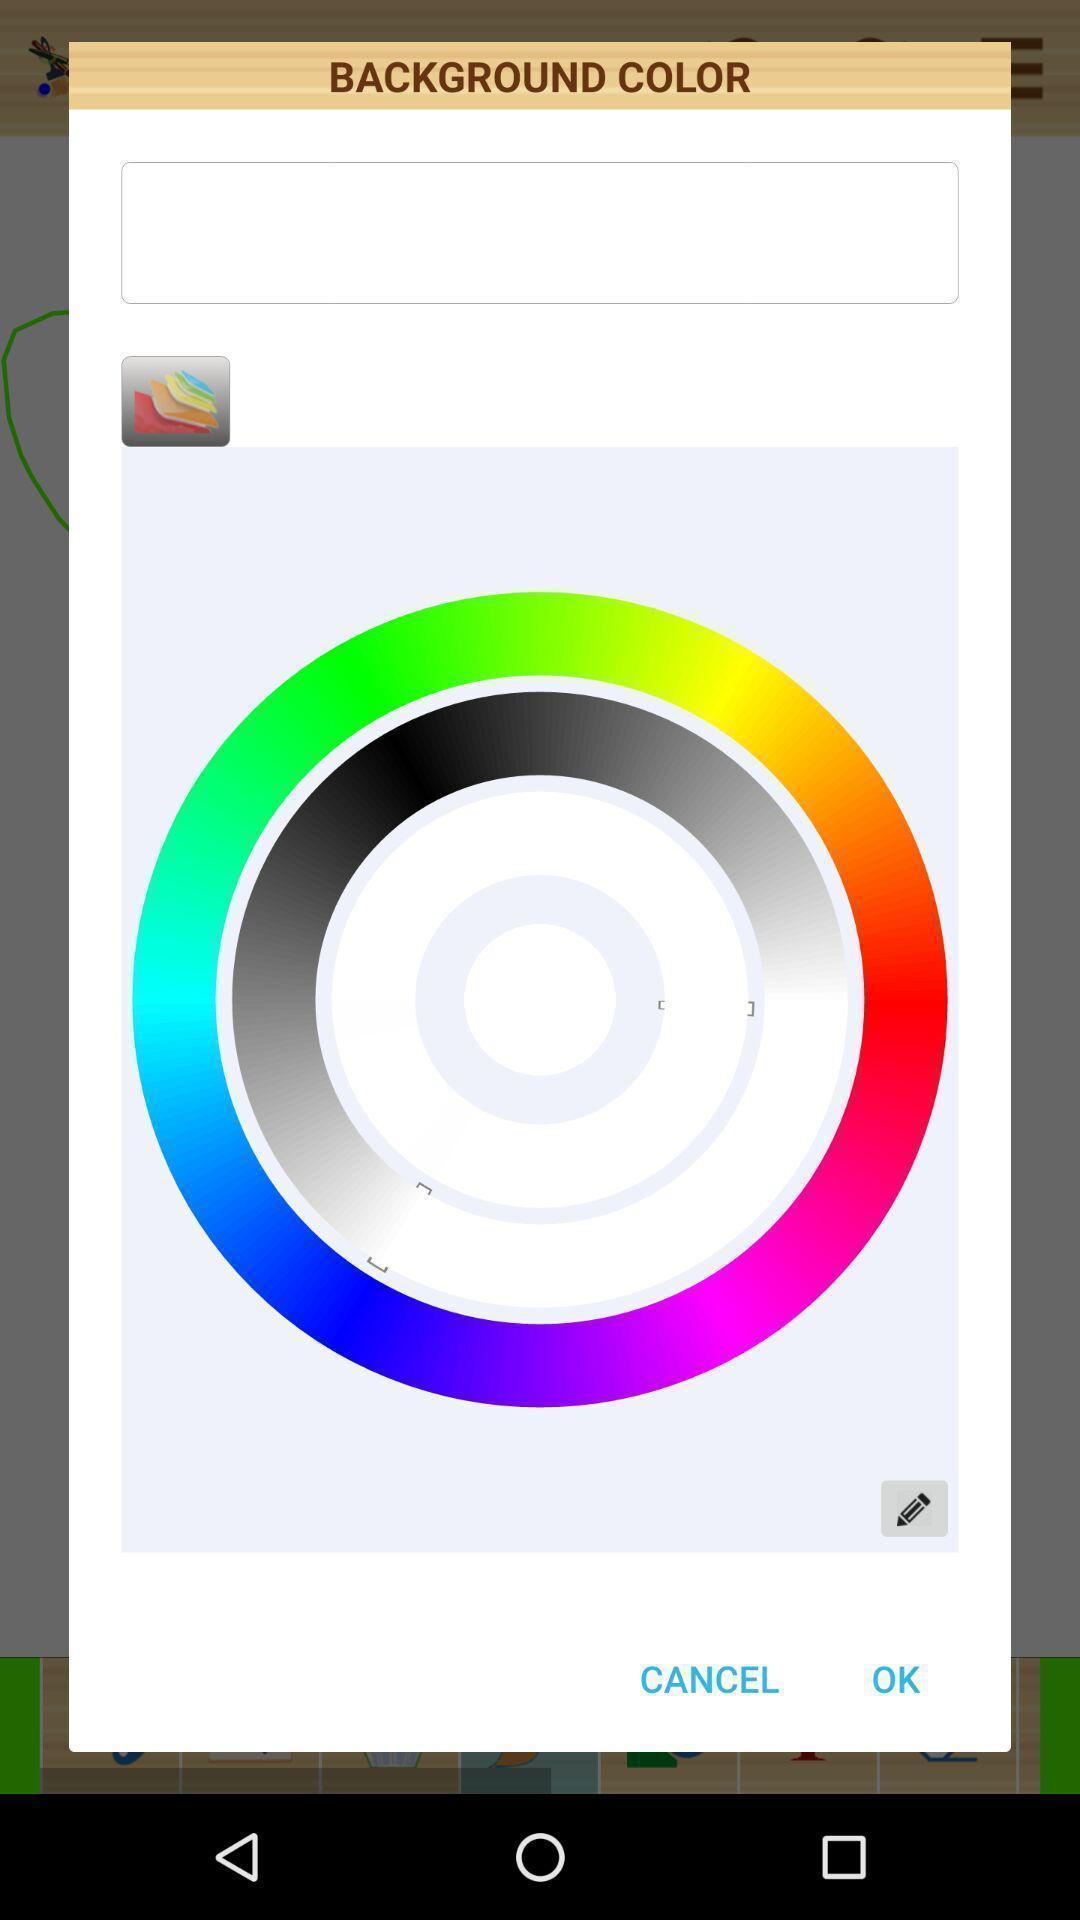Tell me what you see in this picture. Pop-up display background color option. 